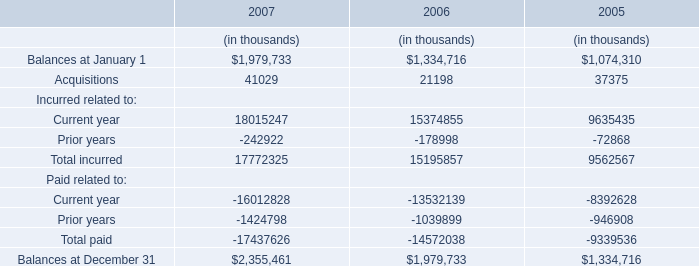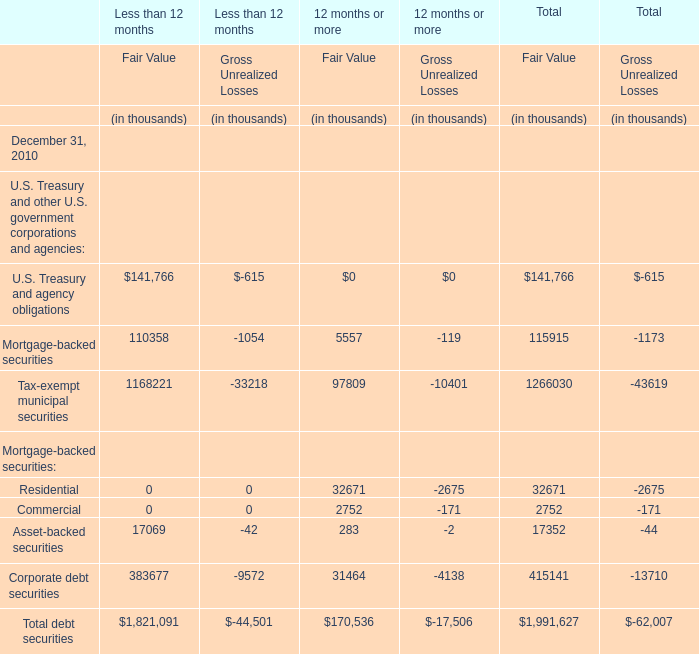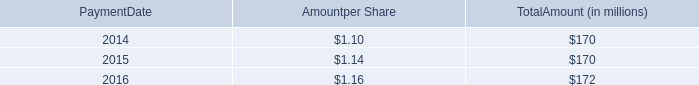What is the column number of the section where the value of Total debt securities is negative for Less than 12 months as of December 31, 2010? 
Answer: 2. 